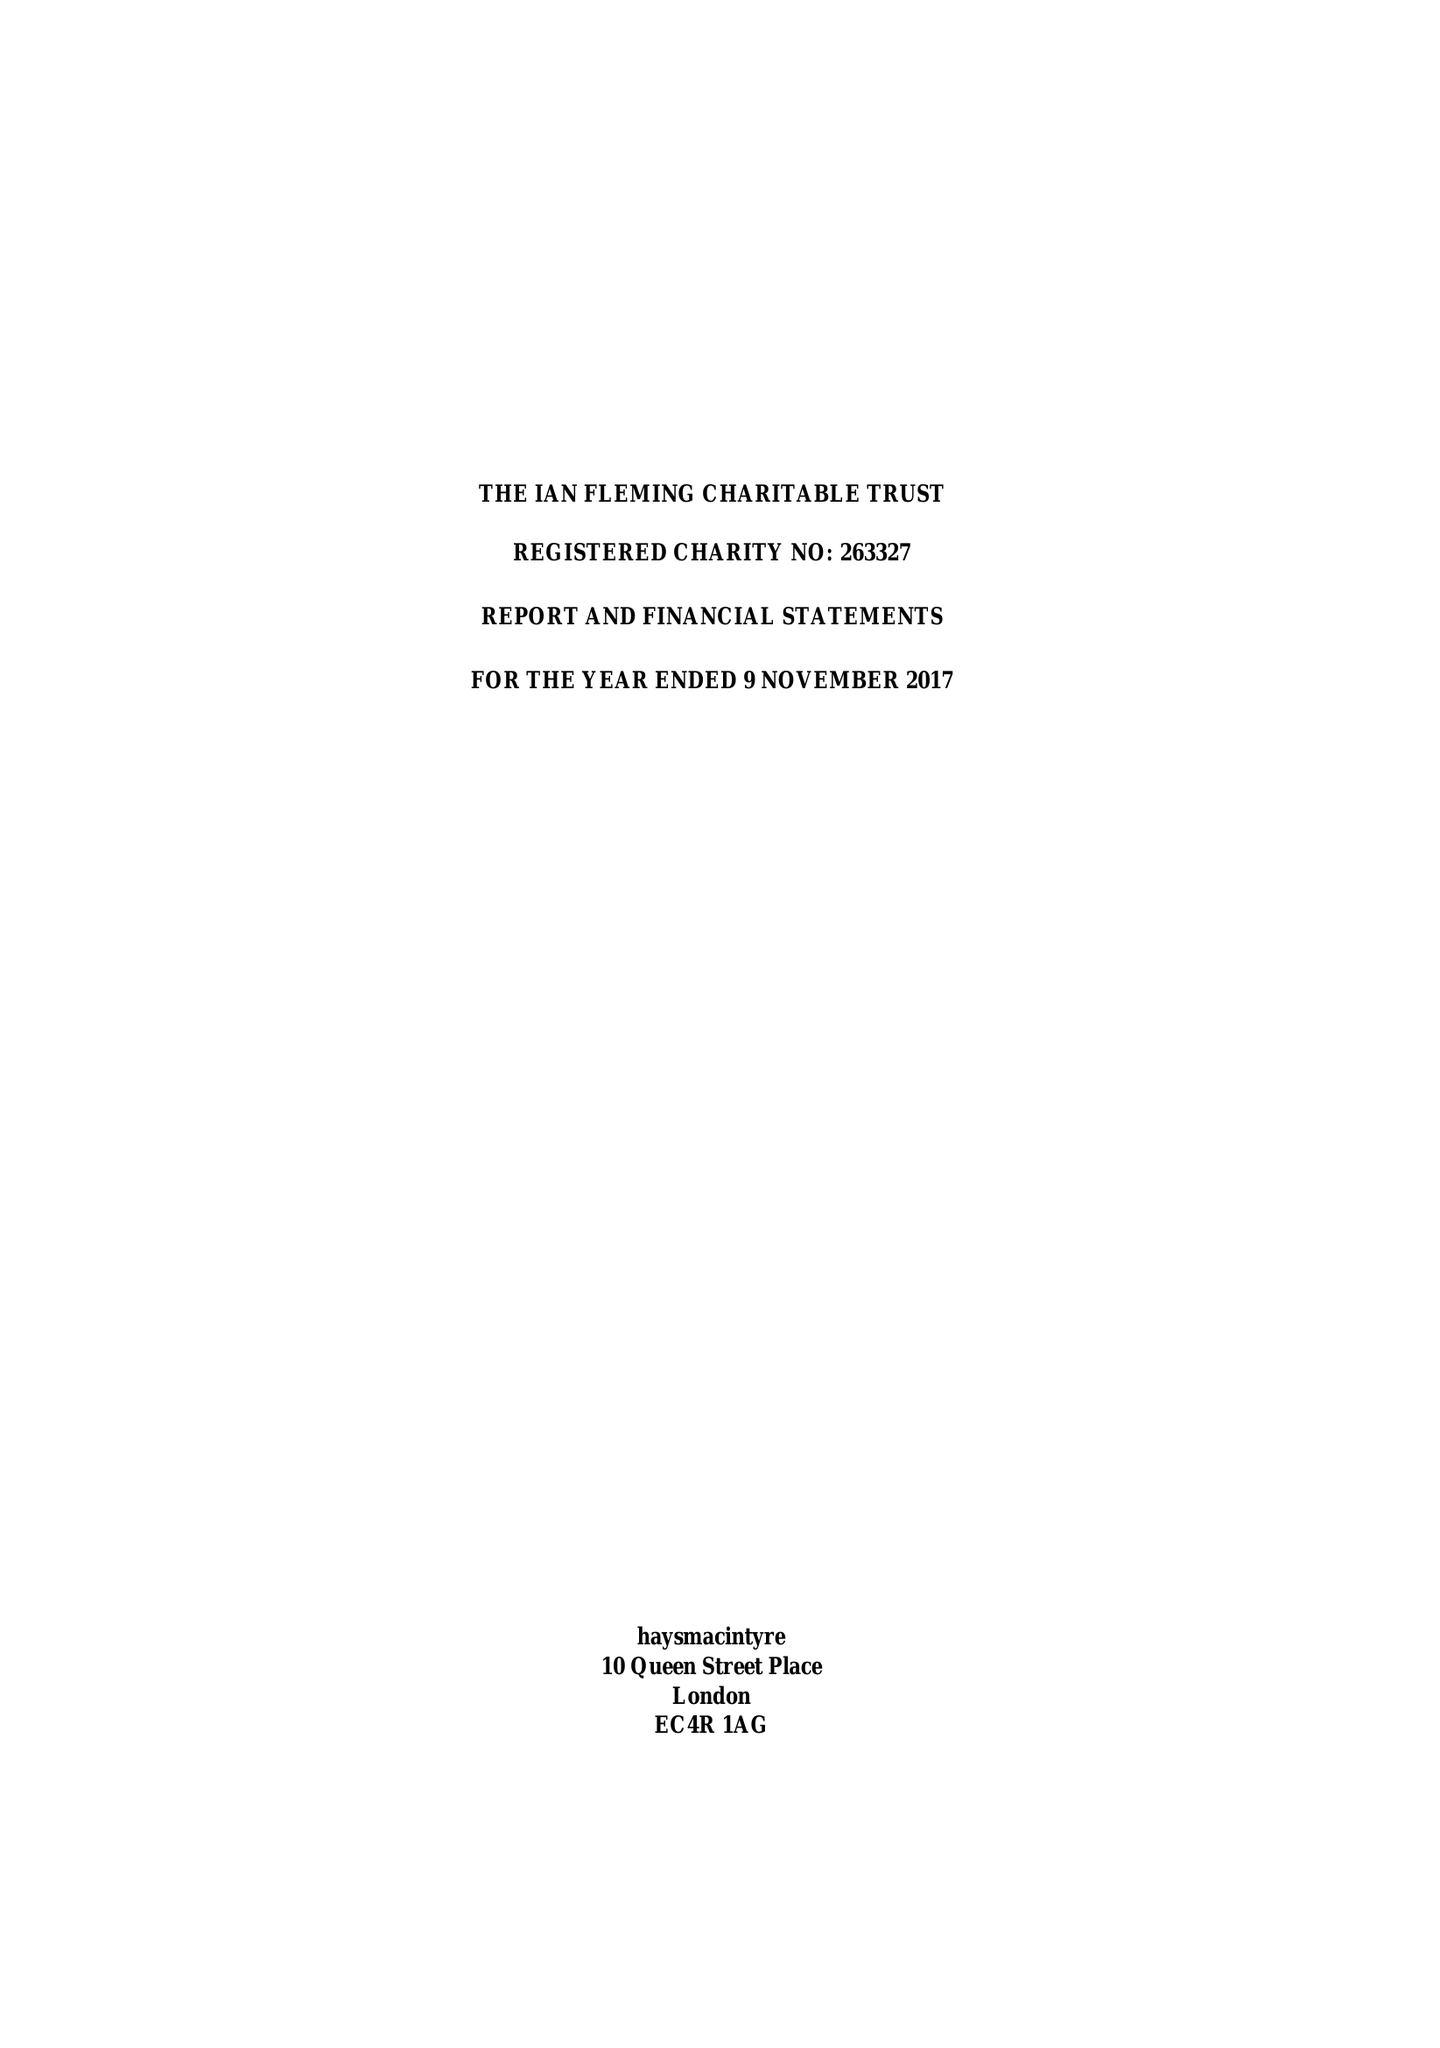What is the value for the address__post_town?
Answer the question using a single word or phrase. LONDON 